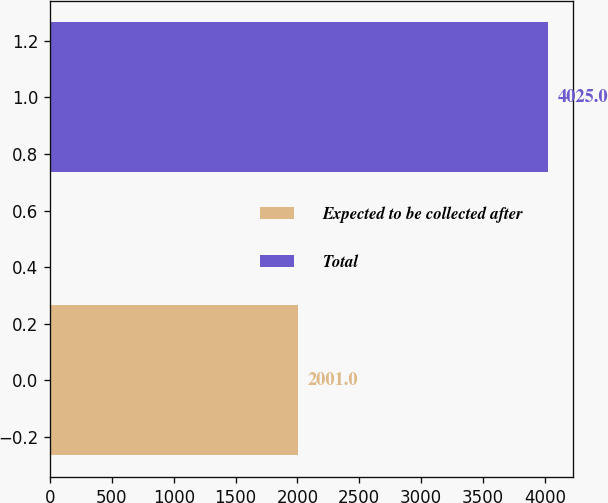Convert chart. <chart><loc_0><loc_0><loc_500><loc_500><bar_chart><fcel>Expected to be collected after<fcel>Total<nl><fcel>2001<fcel>4025<nl></chart> 